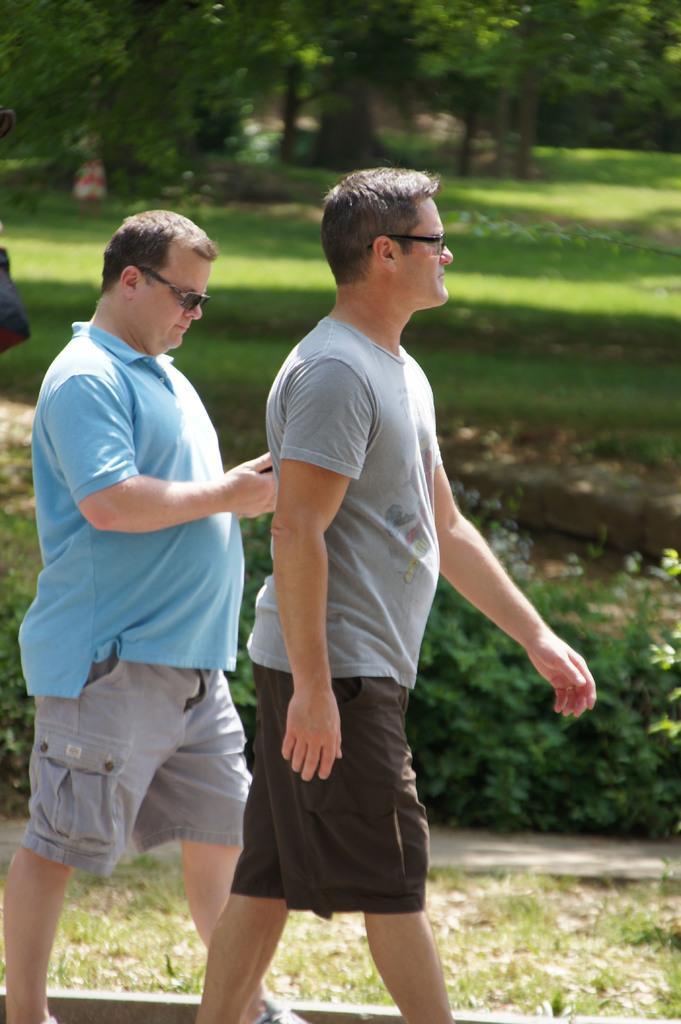Describe this image in one or two sentences. This image is taken outdoors. In the background there are a few trees on the ground and there is a ground with grass on it. There are a few plants. In the middle of the image to men are walking on the road. 